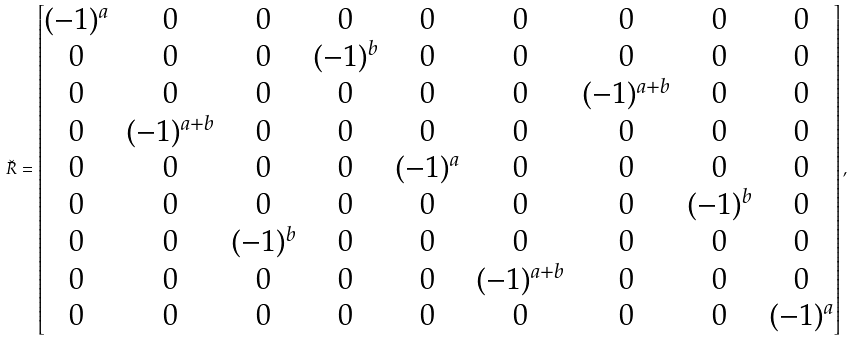Convert formula to latex. <formula><loc_0><loc_0><loc_500><loc_500>\check { R } = \begin{bmatrix} ( - 1 ) ^ { a } & 0 & 0 & 0 & 0 & 0 & 0 & 0 & 0 \\ 0 & 0 & 0 & ( - 1 ) ^ { b } & 0 & 0 & 0 & 0 & 0 \\ 0 & 0 & 0 & 0 & 0 & 0 & ( - 1 ) ^ { a + b } & 0 & 0 \\ 0 & ( - 1 ) ^ { a + b } & 0 & 0 & 0 & 0 & 0 & 0 & 0 \\ 0 & 0 & 0 & 0 & ( - 1 ) ^ { a } & 0 & 0 & 0 & 0 \\ 0 & 0 & 0 & 0 & 0 & 0 & 0 & ( - 1 ) ^ { b } & 0 \\ 0 & 0 & ( - 1 ) ^ { b } & 0 & 0 & 0 & 0 & 0 & 0 \\ 0 & 0 & 0 & 0 & 0 & ( - 1 ) ^ { a + b } & 0 & 0 & 0 \\ 0 & 0 & 0 & 0 & 0 & 0 & 0 & 0 & ( - 1 ) ^ { a } \end{bmatrix} ,</formula> 